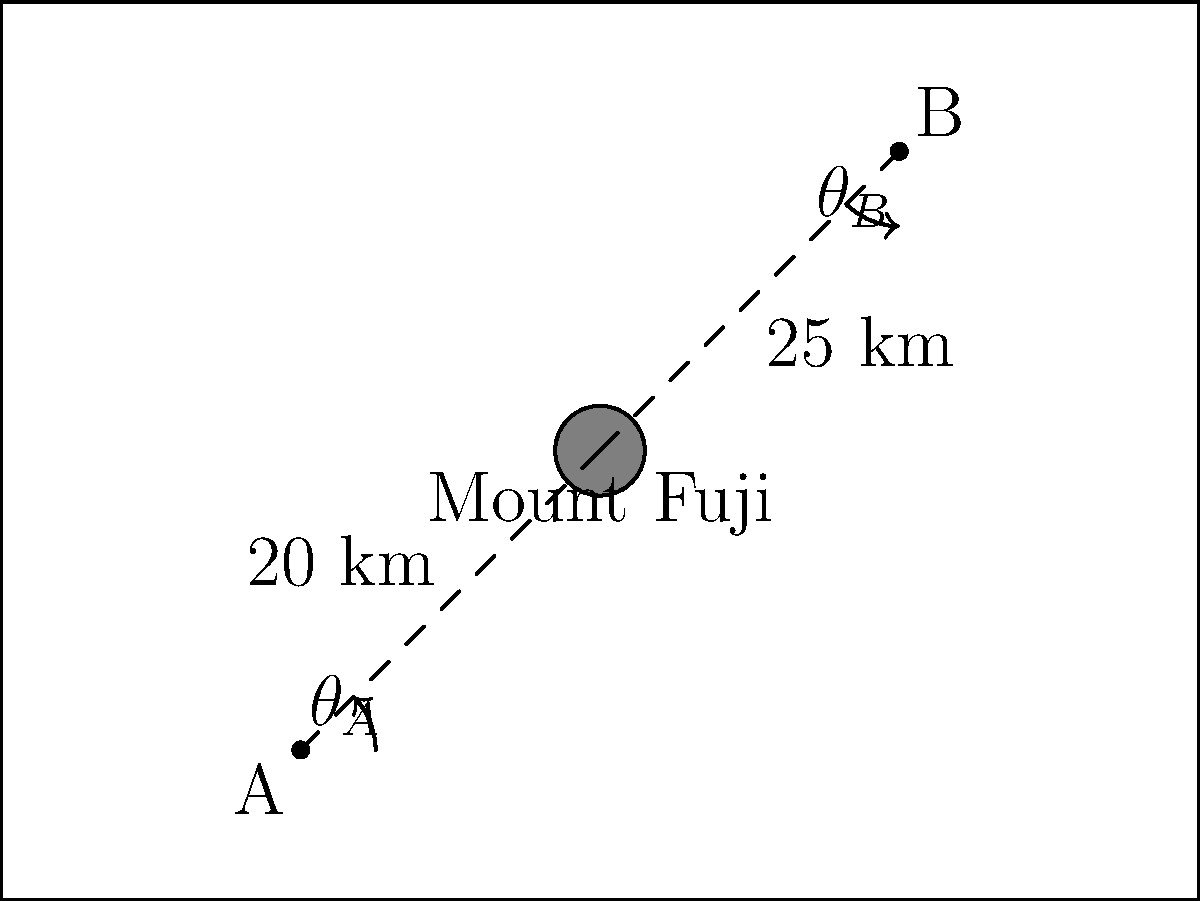Using the topographical map provided, calculate the difference between the viewing angles of Mount Fuji from points A and B. Given that the height of Mount Fuji is 3,776 meters, and assuming the observation points are at sea level, which angle is larger and by how many degrees? To solve this problem, we need to calculate the viewing angles from both points A and B, then find their difference. We'll use the tangent function to calculate these angles.

Step 1: Calculate the viewing angle from point A
Distance from A to Mount Fuji = 20 km = 20,000 m
Height of Mount Fuji = 3,776 m
$\theta_A = \arctan(\frac{3776}{20000}) \approx 10.69°$

Step 2: Calculate the viewing angle from point B
Distance from B to Mount Fuji = 25 km = 25,000 m
Height of Mount Fuji = 3,776 m
$\theta_B = \arctan(\frac{3776}{25000}) \approx 8.58°$

Step 3: Calculate the difference between the angles
Difference = $\theta_A - \theta_B = 10.69° - 8.58° \approx 2.11°$

Therefore, the viewing angle from point A is larger, and the difference between the two angles is approximately 2.11°.
Answer: Point A's angle is larger by 2.11° 